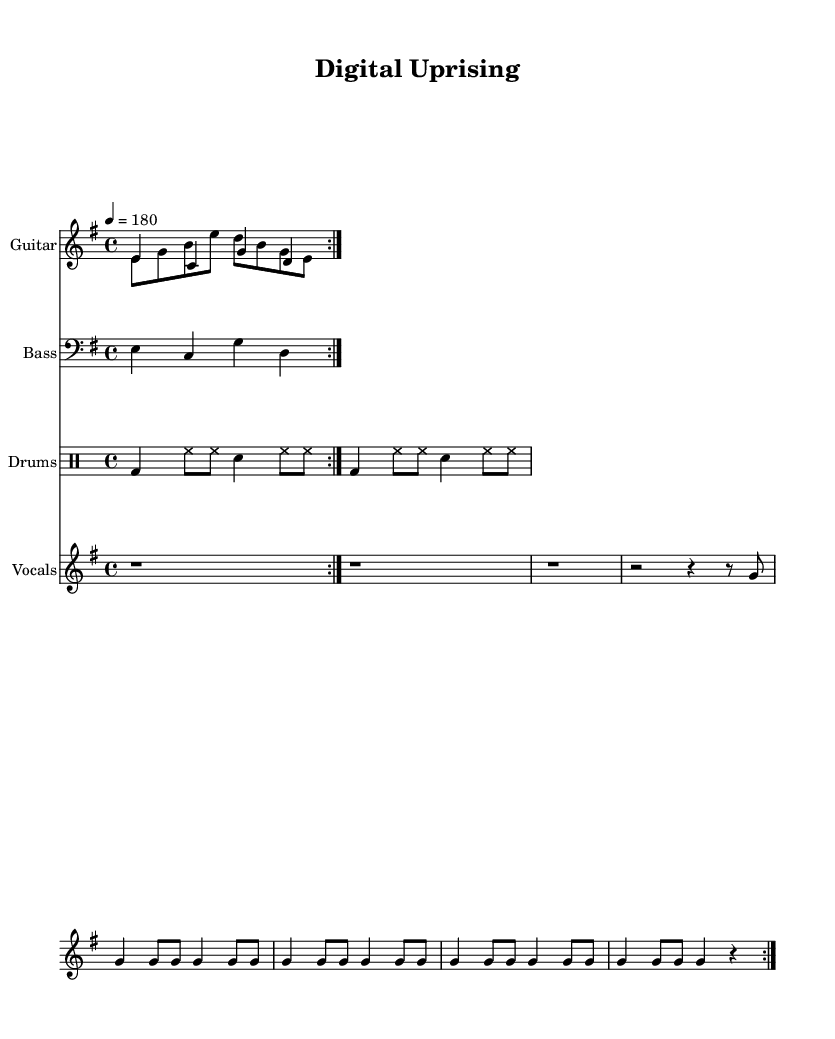What is the key signature of this music? The key signature is E minor, which corresponds to one sharp (F#) and indicates that the music is in a minor key.
Answer: E minor What is the time signature of this music? The time signature is defined at the beginning of the score and is represented as 4/4, meaning there are four beats per measure.
Answer: 4/4 What is the tempo marking for this piece? The tempo marking indicates a speed of quarter note equals 180 beats per minute, which is a fast-paced tempo typical for punk music.
Answer: 180 How many measures are in the guitar part? The guitar part repeats a volta (or repeated section) two times that have a total of four measures, each with two measures per repeat.
Answer: Four measures What is the main theme lyric of this song? The lyrics explicitly celebrate hacker culture and digital rebellion, with phrases like "Bits and bytes, our digital might."
Answer: Bits and bytes, our digital might How many distinct sections are in the vocals part? The vocals part features a single repeated section (voiced via the repetition of the volta) comprising multiple phrases, which has a clear thematic connection to the music.
Answer: One section What does the drumming pattern emphasize in this piece? The drumming pattern features a steady bass drum and hi-hat combination with syncopation that drives the rhythmic energy, essential for the punk style.
Answer: Steady bass and hi-hat 